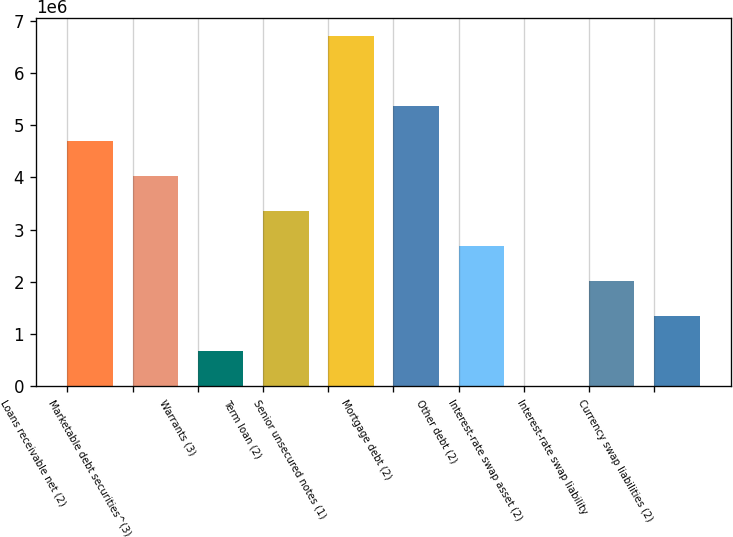<chart> <loc_0><loc_0><loc_500><loc_500><bar_chart><fcel>Loans receivable net (2)<fcel>Marketable debt securities^(3)<fcel>Warrants (3)<fcel>Term loan (2)<fcel>Senior unsecured notes (1)<fcel>Mortgage debt (2)<fcel>Other debt (2)<fcel>Interest-rate swap asset (2)<fcel>Interest-rate swap liability<fcel>Currency swap liabilities (2)<nl><fcel>4.69886e+06<fcel>4.02761e+06<fcel>671342<fcel>3.35636e+06<fcel>6.71262e+06<fcel>5.37012e+06<fcel>2.6851e+06<fcel>89<fcel>2.01385e+06<fcel>1.3426e+06<nl></chart> 